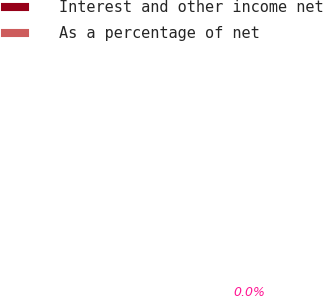Convert chart to OTSL. <chart><loc_0><loc_0><loc_500><loc_500><pie_chart><fcel>Interest and other income net<fcel>As a percentage of net<nl><fcel>100.0%<fcel>0.0%<nl></chart> 